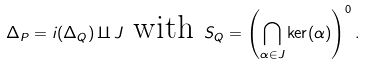<formula> <loc_0><loc_0><loc_500><loc_500>\Delta _ { P } = i ( \Delta _ { Q } ) \amalg J \text { with } S _ { Q } = \left ( \bigcap _ { \alpha \in J } \ker ( \alpha ) \right ) ^ { 0 } .</formula> 